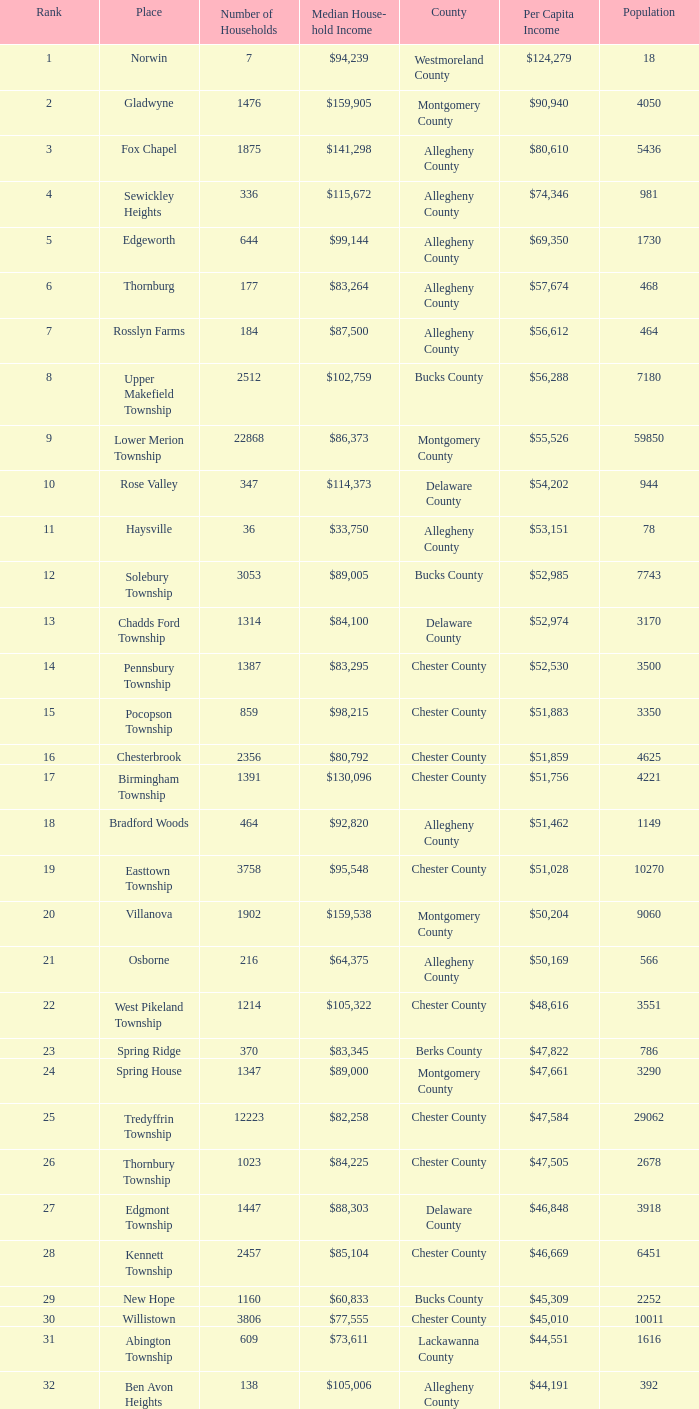What county has 2053 households?  Chester County. 